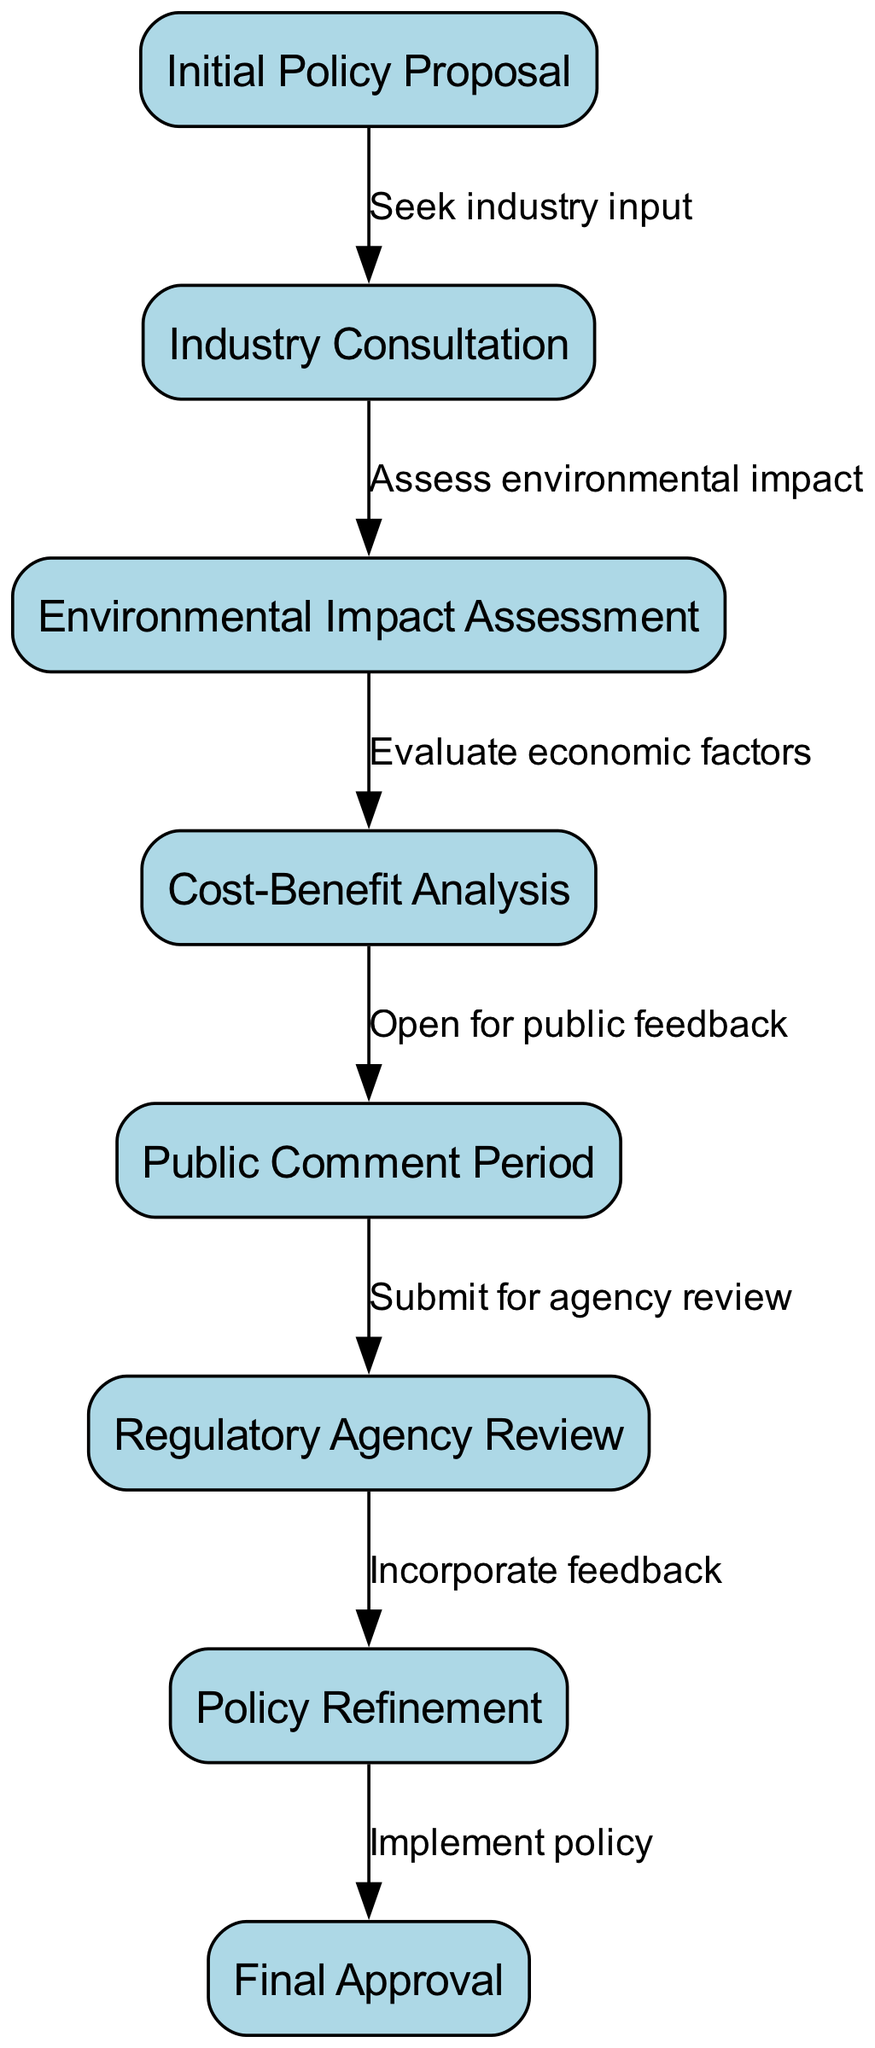What is the first step in the regulatory process? The diagram starts with the "Initial Policy Proposal" as the first step in the regulatory process, indicating that this is where the process begins.
Answer: Initial Policy Proposal How many nodes are in the diagram? The diagram contains a total of eight nodes, representing different stages in the regulatory process for new energy policies.
Answer: Eight What follows the "Industry Consultation" node? After the "Industry Consultation" stage, the next step is "Environmental Impact Assessment," which indicates a sequence in the regulatory process.
Answer: Environmental Impact Assessment What is assessed during the "Environmental Impact Assessment"? The label for the edge leading to the "Environmental Impact Assessment" node indicates that the "Environmental Impact" is assessed during this stage.
Answer: Environmental Impact What happens after the "Public Comment Period"? Following the "Public Comment Period," the process moves to "Regulatory Agency Review," which signifies the next stage in the flow of the diagram.
Answer: Regulatory Agency Review Which step includes incorporating feedback? The "Policy Refinement" step specifically includes incorporating feedback received during the preceding reviews and consultations to improve the policy proposal further.
Answer: Incorporate feedback What is the final step in the regulatory process? The final step in the regulatory process is "Final Approval," marking the conclusion of the policy development and implementation sequence.
Answer: Final Approval How many edges are there connecting nodes? The diagram has a total of seven edges connecting the nodes, illustrating the flow between different stages in the regulatory process.
Answer: Seven Which step involves evaluating economic factors? The step where economic factors are evaluated is the "Cost-Benefit Analysis", as indicated by the label on the edge leading to that node.
Answer: Cost-Benefit Analysis What stage opens the policy up for public feedback? The "Public Comment Period" stage specifically opens the policy for public feedback, allowing stakeholders to voice their opinions.
Answer: Public Comment Period 